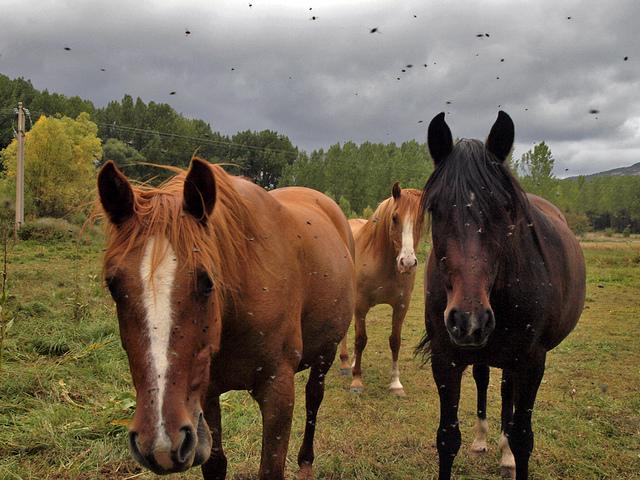What insect is flying?
Write a very short answer. Flies. How many of the horses have black manes?
Answer briefly. 1. Are these animal all looking the same way?
Keep it brief. Yes. Is it a nice day?
Answer briefly. No. Is the sky cloudy?
Answer briefly. Yes. How many horses?
Short answer required. 3. 